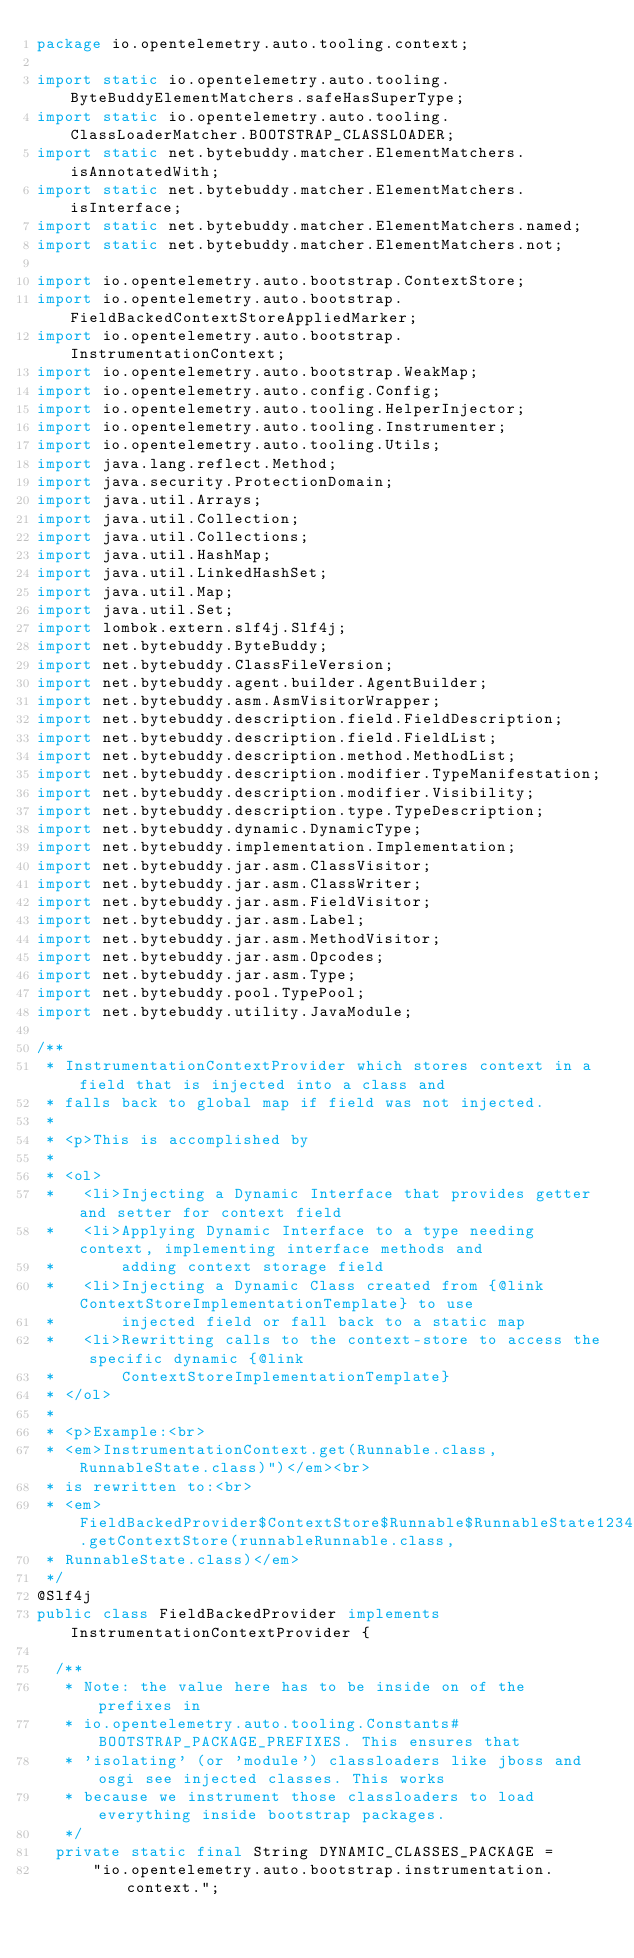<code> <loc_0><loc_0><loc_500><loc_500><_Java_>package io.opentelemetry.auto.tooling.context;

import static io.opentelemetry.auto.tooling.ByteBuddyElementMatchers.safeHasSuperType;
import static io.opentelemetry.auto.tooling.ClassLoaderMatcher.BOOTSTRAP_CLASSLOADER;
import static net.bytebuddy.matcher.ElementMatchers.isAnnotatedWith;
import static net.bytebuddy.matcher.ElementMatchers.isInterface;
import static net.bytebuddy.matcher.ElementMatchers.named;
import static net.bytebuddy.matcher.ElementMatchers.not;

import io.opentelemetry.auto.bootstrap.ContextStore;
import io.opentelemetry.auto.bootstrap.FieldBackedContextStoreAppliedMarker;
import io.opentelemetry.auto.bootstrap.InstrumentationContext;
import io.opentelemetry.auto.bootstrap.WeakMap;
import io.opentelemetry.auto.config.Config;
import io.opentelemetry.auto.tooling.HelperInjector;
import io.opentelemetry.auto.tooling.Instrumenter;
import io.opentelemetry.auto.tooling.Utils;
import java.lang.reflect.Method;
import java.security.ProtectionDomain;
import java.util.Arrays;
import java.util.Collection;
import java.util.Collections;
import java.util.HashMap;
import java.util.LinkedHashSet;
import java.util.Map;
import java.util.Set;
import lombok.extern.slf4j.Slf4j;
import net.bytebuddy.ByteBuddy;
import net.bytebuddy.ClassFileVersion;
import net.bytebuddy.agent.builder.AgentBuilder;
import net.bytebuddy.asm.AsmVisitorWrapper;
import net.bytebuddy.description.field.FieldDescription;
import net.bytebuddy.description.field.FieldList;
import net.bytebuddy.description.method.MethodList;
import net.bytebuddy.description.modifier.TypeManifestation;
import net.bytebuddy.description.modifier.Visibility;
import net.bytebuddy.description.type.TypeDescription;
import net.bytebuddy.dynamic.DynamicType;
import net.bytebuddy.implementation.Implementation;
import net.bytebuddy.jar.asm.ClassVisitor;
import net.bytebuddy.jar.asm.ClassWriter;
import net.bytebuddy.jar.asm.FieldVisitor;
import net.bytebuddy.jar.asm.Label;
import net.bytebuddy.jar.asm.MethodVisitor;
import net.bytebuddy.jar.asm.Opcodes;
import net.bytebuddy.jar.asm.Type;
import net.bytebuddy.pool.TypePool;
import net.bytebuddy.utility.JavaModule;

/**
 * InstrumentationContextProvider which stores context in a field that is injected into a class and
 * falls back to global map if field was not injected.
 *
 * <p>This is accomplished by
 *
 * <ol>
 *   <li>Injecting a Dynamic Interface that provides getter and setter for context field
 *   <li>Applying Dynamic Interface to a type needing context, implementing interface methods and
 *       adding context storage field
 *   <li>Injecting a Dynamic Class created from {@link ContextStoreImplementationTemplate} to use
 *       injected field or fall back to a static map
 *   <li>Rewritting calls to the context-store to access the specific dynamic {@link
 *       ContextStoreImplementationTemplate}
 * </ol>
 *
 * <p>Example:<br>
 * <em>InstrumentationContext.get(Runnable.class, RunnableState.class)")</em><br>
 * is rewritten to:<br>
 * <em>FieldBackedProvider$ContextStore$Runnable$RunnableState12345.getContextStore(runnableRunnable.class,
 * RunnableState.class)</em>
 */
@Slf4j
public class FieldBackedProvider implements InstrumentationContextProvider {

  /**
   * Note: the value here has to be inside on of the prefixes in
   * io.opentelemetry.auto.tooling.Constants#BOOTSTRAP_PACKAGE_PREFIXES. This ensures that
   * 'isolating' (or 'module') classloaders like jboss and osgi see injected classes. This works
   * because we instrument those classloaders to load everything inside bootstrap packages.
   */
  private static final String DYNAMIC_CLASSES_PACKAGE =
      "io.opentelemetry.auto.bootstrap.instrumentation.context.";
</code> 